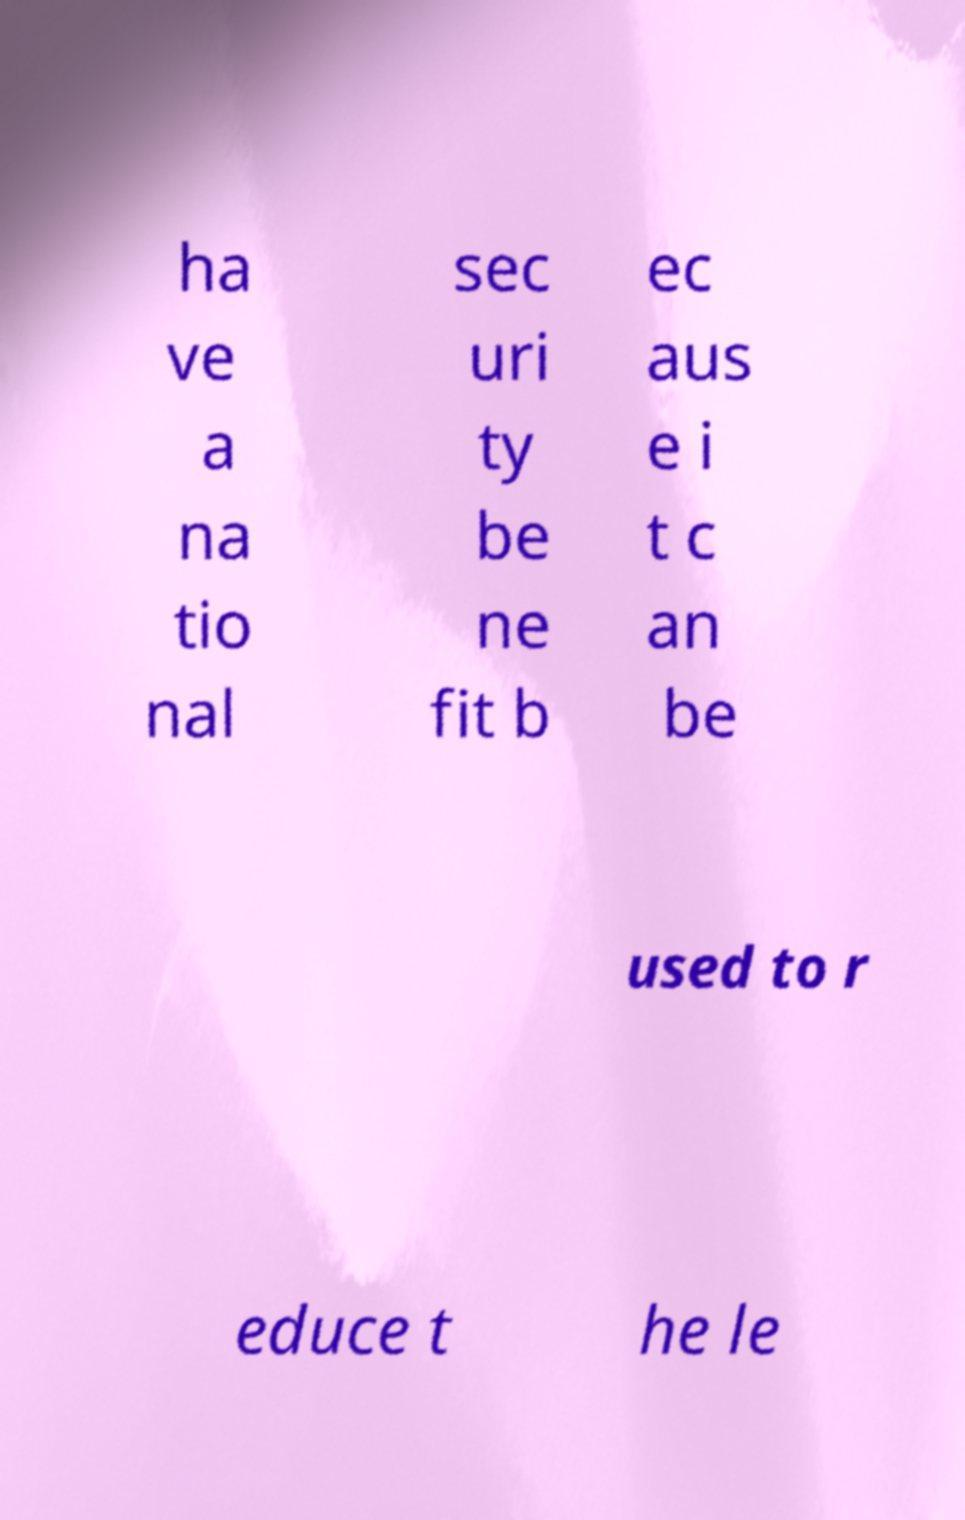Can you accurately transcribe the text from the provided image for me? ha ve a na tio nal sec uri ty be ne fit b ec aus e i t c an be used to r educe t he le 